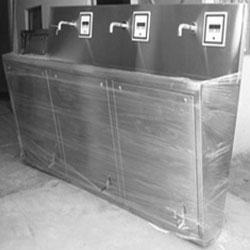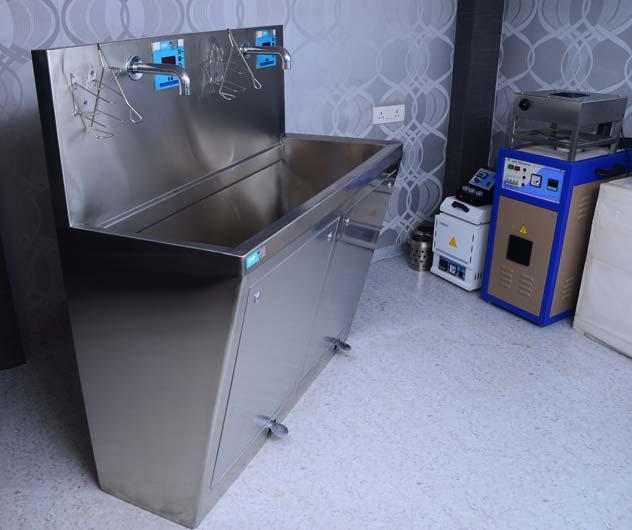The first image is the image on the left, the second image is the image on the right. Analyze the images presented: Is the assertion "There are exactly five faucets." valid? Answer yes or no. Yes. 